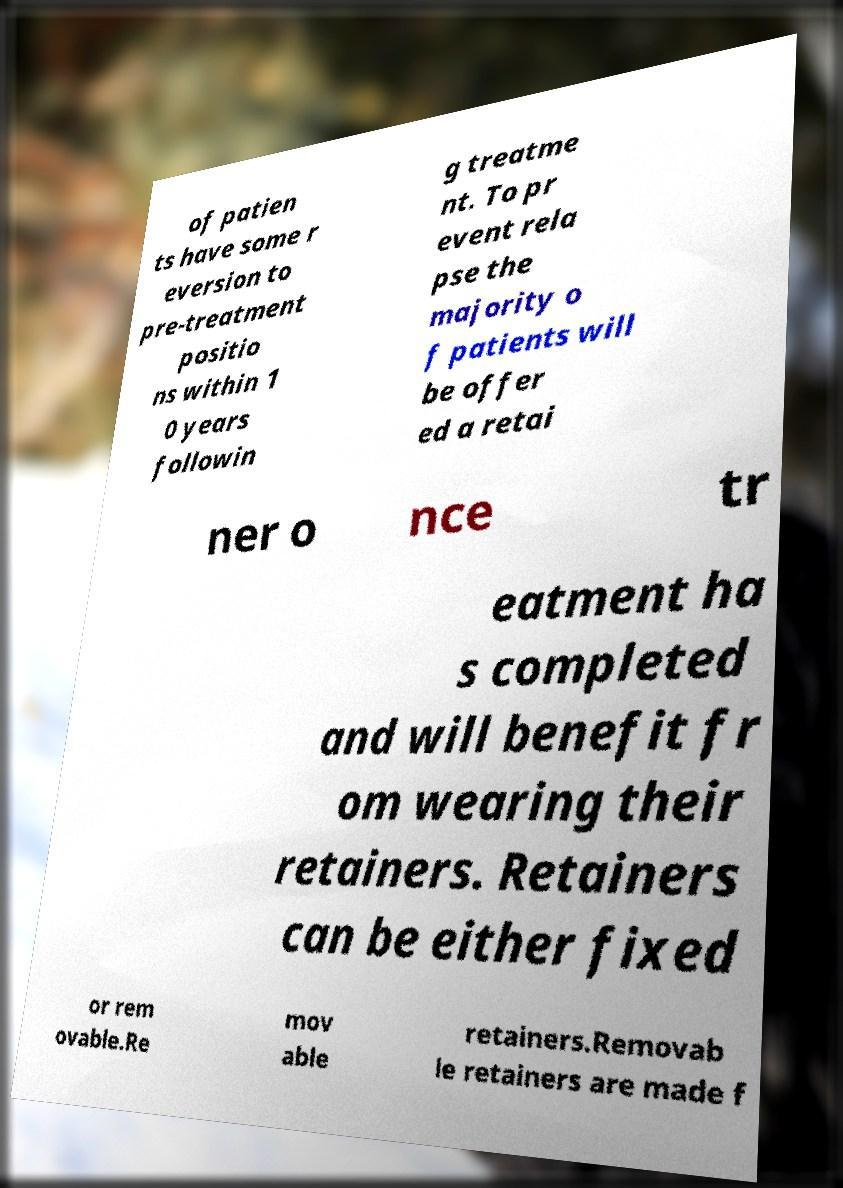Can you accurately transcribe the text from the provided image for me? of patien ts have some r eversion to pre-treatment positio ns within 1 0 years followin g treatme nt. To pr event rela pse the majority o f patients will be offer ed a retai ner o nce tr eatment ha s completed and will benefit fr om wearing their retainers. Retainers can be either fixed or rem ovable.Re mov able retainers.Removab le retainers are made f 